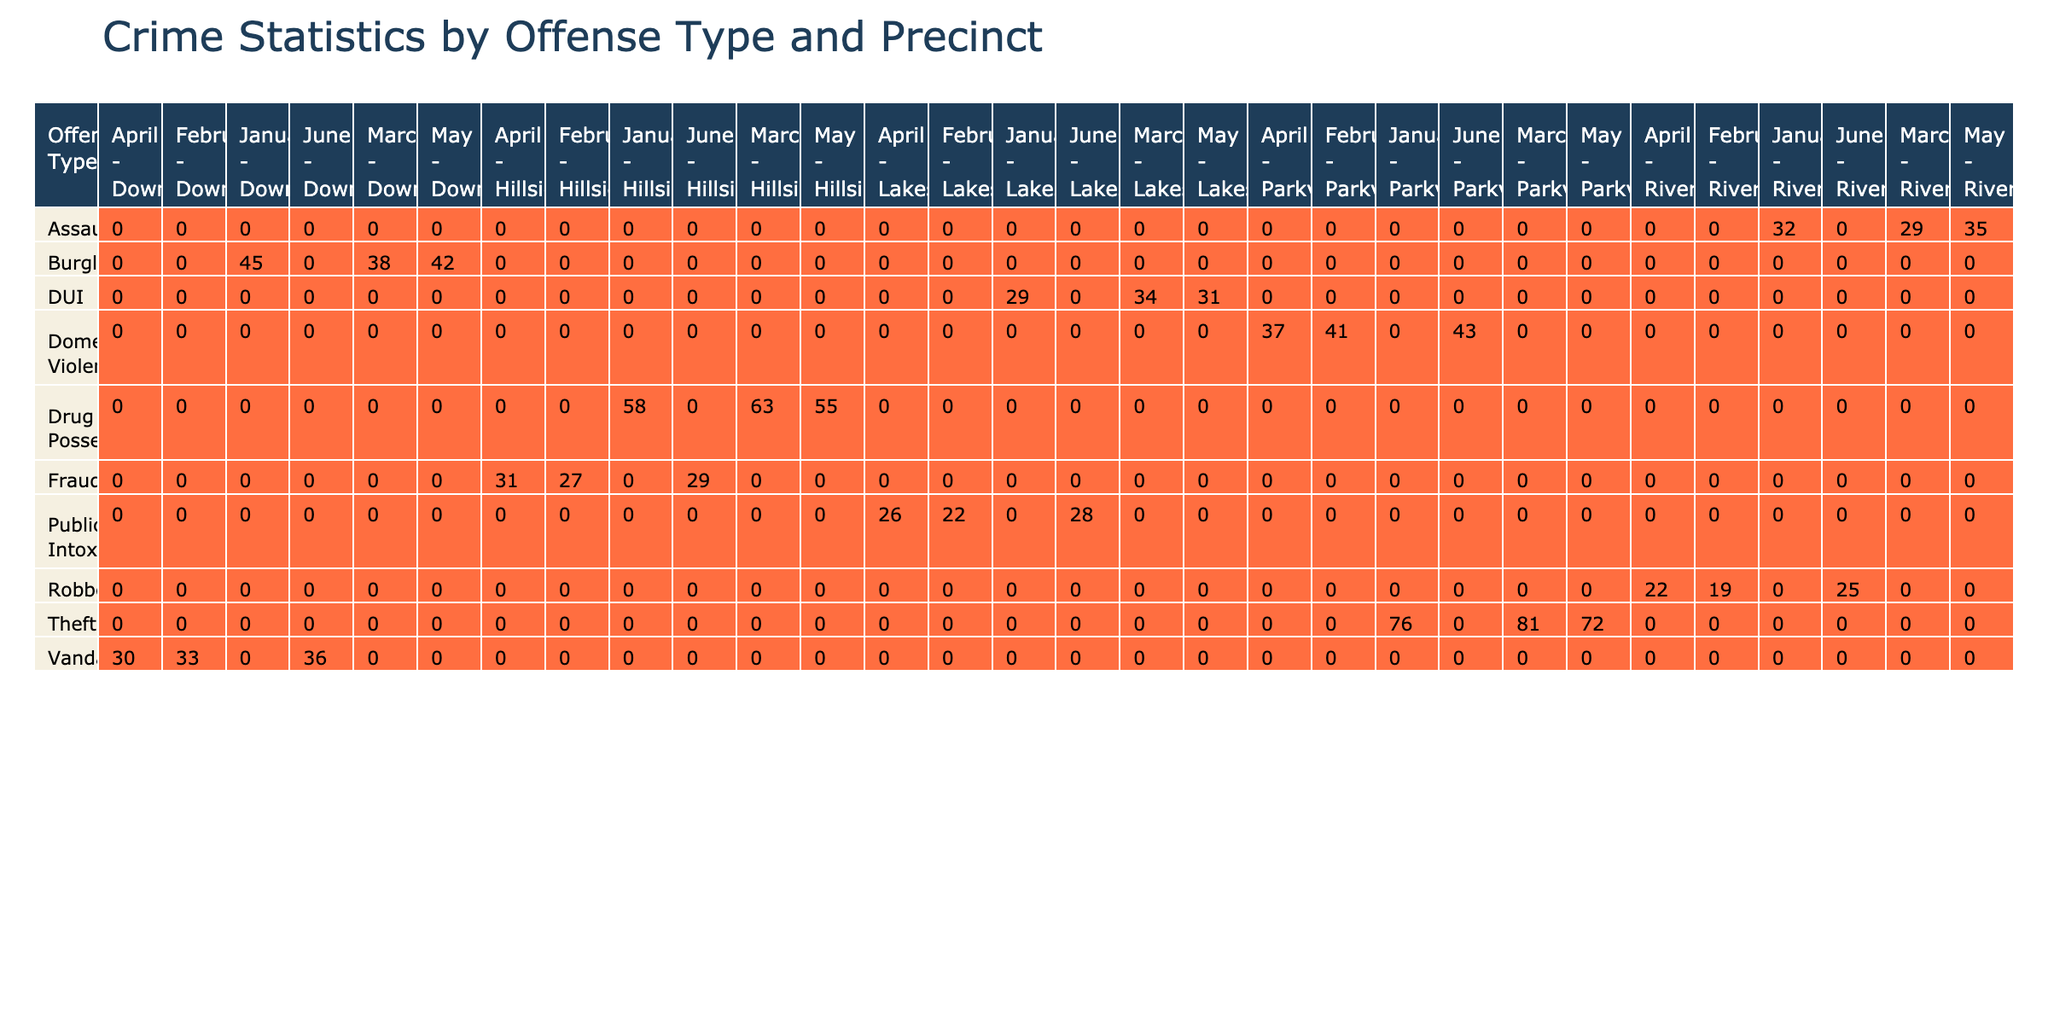What was the total number of burglary cases recorded in Downtown precinct over the past year? To find the total number of burglary cases in Downtown, I look at the two entries for burglary in January and March. Adding these cases together: 45 (January) + 38 (March) + 42 (May) = 125.
Answer: 125 Which precinct had the highest number of drug possession cases? I compare the total drug possession cases across all precincts. The cases are: Hillside for January (58), March (63), and May (55), which totals to 176. The other precincts recorded lower totals, confirming that Hillside has the highest at 176.
Answer: Hillside What percentage of theft cases were cleared across all months in Parkview? To find this percentage, I first sum the number of cases (76+81+72)=229. Then, I sum the cases cleared (39+42+36)=117. The percentage of cases cleared is (117/229)*100 = 51.1%.
Answer: 51.1% Did Riverside precinct have more assault cases than domestic violence cases throughout the year? I total the number of cases for assault (32+29+35)=96 and for domestic violence (41+37)=78 in Riverside. Since 96 > 78, Riverside had more assault cases.
Answer: Yes What was the average number of robbery cases per month in Riverside? There are three recorded months for robbery cases in Riverside: 19 (February), 22 (April), and 25 (June). The total is 19 + 22 + 25 = 66. To find the average, I divide by the number of months: 66/3 = 22.
Answer: 22 Which month had the highest number of vandalism cases in Downtown? I look through the table for Downtown precinct’s vandalism cases. The values are 33 (February) and 36 (June). June has the higher count of 36, making it the month with the highest vandalism cases in Downtown.
Answer: June How many arrests were made for public intoxication across all months in Lakeshore? I examine the table entries for Lakeshore's public intoxication cases: 22 (February), 26 (April), and 28 (June). Adding the arrests gives 22 + 26 + 28 = 76 arrests made in total.
Answer: 76 What is the total number of domestic violence cases recorded in Parkview? There are two entries for domestic violence in the table: January (41) and June (43). Adding these, I get a total of 41 + 43 = 84.
Answer: 84 Which offense type had the most total cases cleared over the year? I will sum the cases cleared for each offense type: For assault= 28+25+30=83, burglary= 22+19+21=62, drug possession= 55+60+52=167, theft= 39+42+36=117, DUI= 29+34+31=94, vandalism= 15+14+16=45, robbery= 11+13+15=39, domestic violence= 38+40=78. Drug possession had the highest at 167.
Answer: Drug Possession 